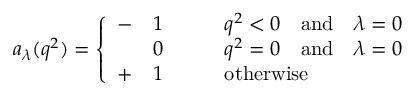<formula> <loc_0><loc_0><loc_500><loc_500>a _ { \lambda } ( q ^ { 2 } ) = \left \{ \begin{array} { l l l } { - } & { 1 } & { { \quad q ^ { 2 } < 0 \quad a n d \quad \lambda = 0 } } & { 0 } & { { \quad q ^ { 2 } = 0 \quad a n d \quad \lambda = 0 } } \\ { + } & { 1 } & { \quad o t h e r w i s e } \end{array}</formula> 